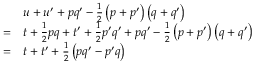Convert formula to latex. <formula><loc_0><loc_0><loc_500><loc_500>{ \begin{array} { r l } & { u + u ^ { \prime } + p q ^ { \prime } - { \frac { 1 } { 2 } } \left ( p + p ^ { \prime } \right ) \left ( q + q ^ { \prime } \right ) } \\ { = } & { t + { \frac { 1 } { 2 } } p q + t ^ { \prime } + { \frac { 1 } { 2 } } p ^ { \prime } q ^ { \prime } + p q ^ { \prime } - { \frac { 1 } { 2 } } \left ( p + p ^ { \prime } \right ) \left ( q + q ^ { \prime } \right ) } \\ { = } & { t + t ^ { \prime } + { \frac { 1 } { 2 } } \left ( p q ^ { \prime } - p ^ { \prime } q \right ) } \end{array} }</formula> 